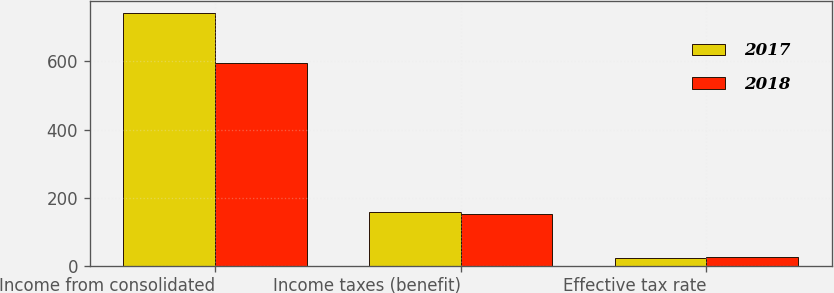Convert chart. <chart><loc_0><loc_0><loc_500><loc_500><stacked_bar_chart><ecel><fcel>Income from consolidated<fcel>Income taxes (benefit)<fcel>Effective tax rate<nl><fcel>2017<fcel>741.3<fcel>157.3<fcel>21.2<nl><fcel>2018<fcel>594.8<fcel>151.3<fcel>25.4<nl></chart> 